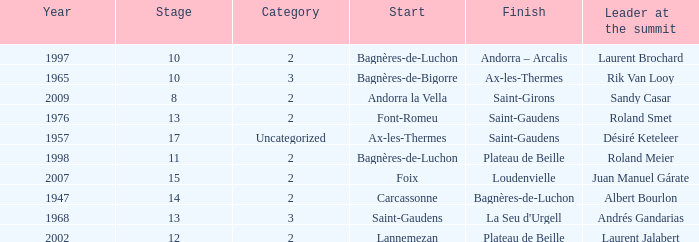Name the start of an event in Catagory 2 of the year 1947. Carcassonne. 